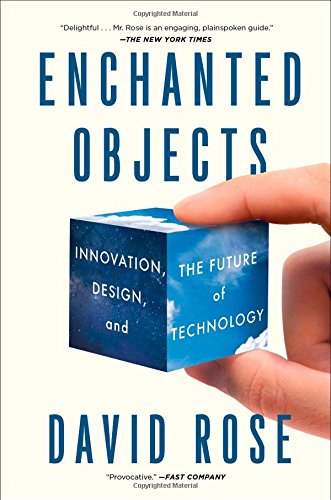Is this an art related book? While 'Enchanted Objects' does involve elements of Art through its focus on design aesthetics, its primary focus lies in showcasing how technology can infuse objects with new functionality, transforming them into enchanting experiences. 